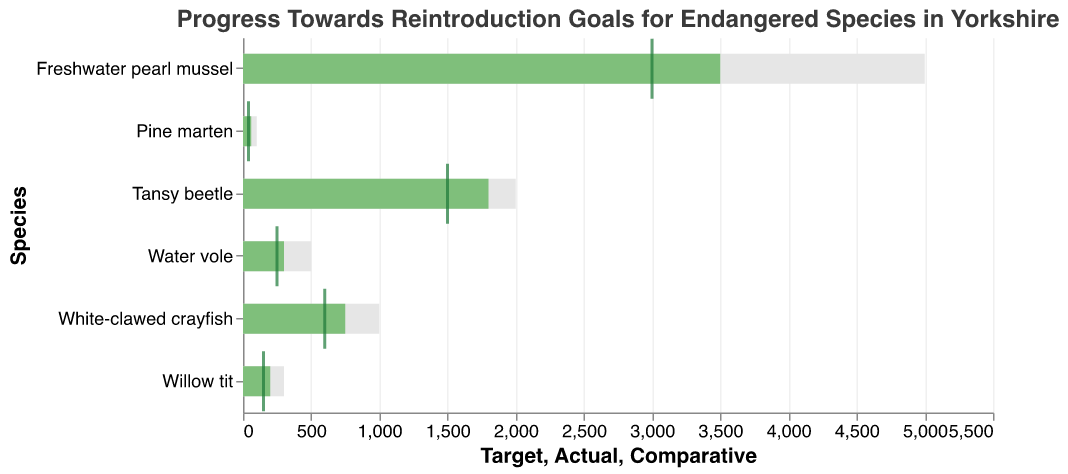What is the title of the chart? The title is usually displayed at the top of the chart and provides a brief description of the chart's purpose. In this case, the title is "Progress Towards Reintroduction Goals for Endangered Species in Yorkshire."
Answer: Progress Towards Reintroduction Goals for Endangered Species in Yorkshire What species has the highest target for reintroduction? The species with the highest bar under the "Target" category is the Freshwater pearl mussel, which has a target reintroduction goal of 5000 individuals.
Answer: Freshwater pearl mussel Which species has the smallest difference between its actual and target numbers? To find this, we'll look at each species and subtract its actual figure from the target figure. For the Tansy beetle, the difference is the smallest: 
Tansy beetle: 2000 - 1800 = 200, 
Freshwater pearl mussel: 5000 - 3500 = 1500,
White-clawed crayfish: 1000 - 750 = 250,
Willow tit: 300 - 200 = 100,
Water vole: 500 - 300 = 200,
Pine marten: 100 - 60 = 40.
Thus, Pine marten has the smallest difference.
Answer: Pine marten What species has the highest actual reintroduction numbers? Comparing the actual reintroduction numbers (the "Actual" values) across all species, the highest number is 3500, which is under Freshwater pearl mussel.
Answer: Freshwater pearl mussel Which species' actual numbers are closest to its comparative hint? We need to look at the "Actual" and "Comparative" values. The species with the smallest difference between these two values is White-clawed crayfish (750 actual vs. 600 comparative), giving a difference of 150:
White-clawed crayfish: 150,
Water vole: 50,
Tansy beetle: 300,
Pine marten: 20,
Freshwater pearl mussel: 500,
Willow tit: 50.
Answer: Pine marten What species show the greatest progress towards its target? Progress can be understood as the percentage of the actual reintroduction relative to the target value. Generally, this involves the division and comparison such as:
Tansy beetle: (1800 / 2000) * 100 = 90%,
Freshwater pearl mussel: (3500 / 5000) * 100 = 70%,
White-clawed crayfish: (750 / 1000) * 100 = 75%,
Willow tit: (200 / 300) * 100 = 66.7%,
Water vole: (300 / 500) * 100 = 60%,
Pine marten: (60 / 100) * 100 = 60%.
Thus, Tansy beetle has the highest progress at 90%.
Answer: Tansy beetle Which species has achieved more than half of its reintroduction target? Calculating whether actual numbers exceed 50% of target values:
White-clawed crayfish: 750 / 1000 = 0.75 (yes),
Water vole: 300 / 500 = 0.6 (yes),
Tansy beetle: 1800 / 2000 = 0.9 (yes),
Pine marten: 60 / 100 = 0.6 (yes),
Freshwater pearl mussel: 3500 / 5000 = 0.7 (yes),
Willow tit: 200 / 300 = 0.67 (yes).
All species have achieved at least half of their reintroduction target.
Answer: All species Which species has the greatest potential for improvement based on the comparative value? This involves identifying which species has the largest difference between comparative numbers and target numbers:
White-clawed crayfish: 1000 - 600 = 400,
Water vole: 500 - 250 = 250,
Tansy beetle: 2000 - 1500 = 500,
Pine marten: 100 - 40 = 60,
Freshwater pearl mussel: 5000 - 3000 = 2000,
Willow tit: 300 - 150 = 150.
Thus, Freshwater pearl mussel has the greatest potential for improvement with a difference of 2000.
Answer: Freshwater pearl mussel 